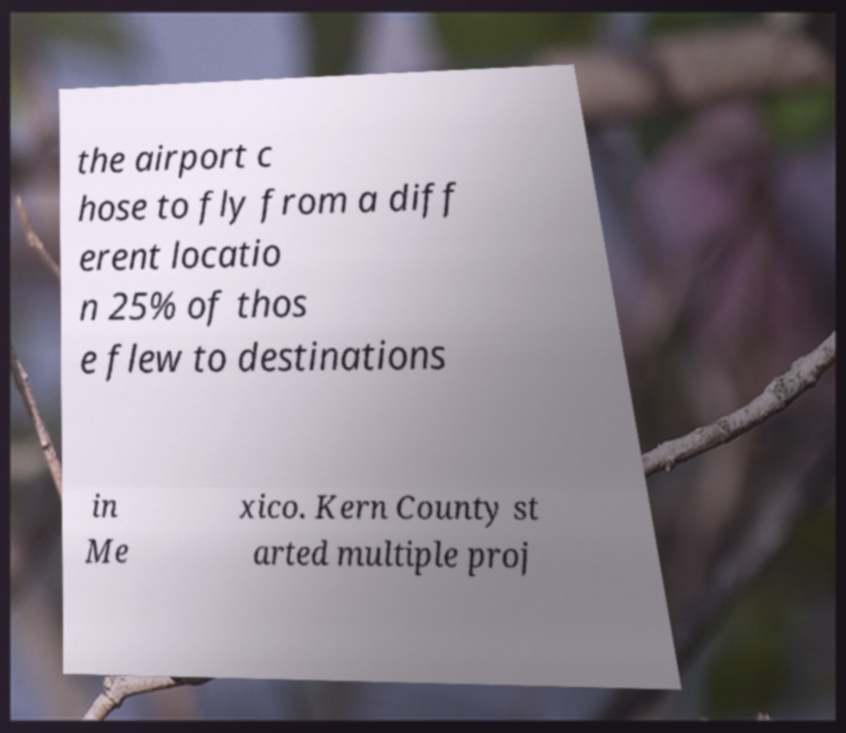Could you extract and type out the text from this image? the airport c hose to fly from a diff erent locatio n 25% of thos e flew to destinations in Me xico. Kern County st arted multiple proj 